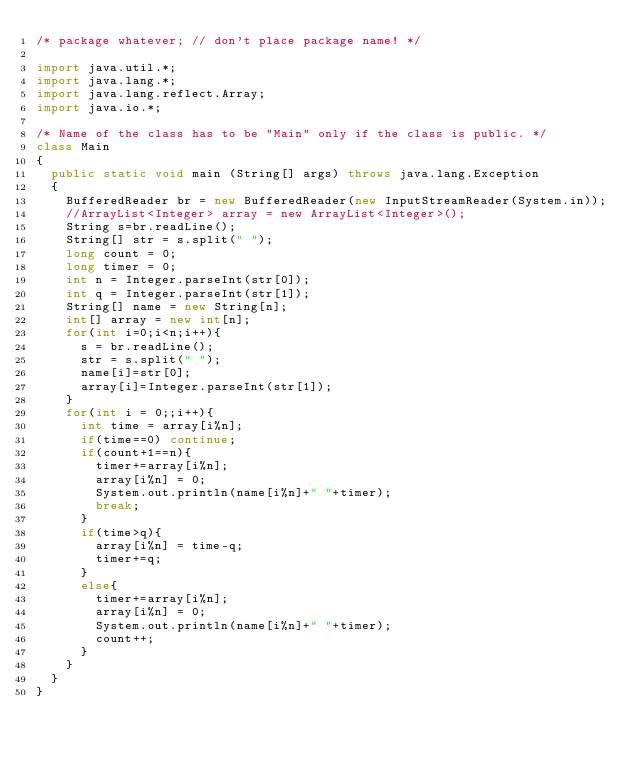Convert code to text. <code><loc_0><loc_0><loc_500><loc_500><_Java_>/* package whatever; // don't place package name! */

import java.util.*;
import java.lang.*;
import java.lang.reflect.Array;
import java.io.*;

/* Name of the class has to be "Main" only if the class is public. */
class Main
{
	public static void main (String[] args) throws java.lang.Exception
	{
		BufferedReader br = new BufferedReader(new InputStreamReader(System.in));
		//ArrayList<Integer> array = new ArrayList<Integer>();
		String s=br.readLine();
		String[] str = s.split(" ");
		long count = 0;
		long timer = 0;
		int n = Integer.parseInt(str[0]);
		int q = Integer.parseInt(str[1]);
		String[] name = new String[n];
		int[] array = new int[n];
		for(int i=0;i<n;i++){
			s = br.readLine();
			str = s.split(" ");
			name[i]=str[0];
			array[i]=Integer.parseInt(str[1]);
		}
		for(int i = 0;;i++){
			int time = array[i%n];
			if(time==0) continue;
			if(count+1==n){
				timer+=array[i%n];
				array[i%n] = 0;
				System.out.println(name[i%n]+" "+timer);
				break;
			}
			if(time>q){
				array[i%n] = time-q;
				timer+=q;
			}
			else{
				timer+=array[i%n];
				array[i%n] = 0;
				System.out.println(name[i%n]+" "+timer);
				count++;
			}	
		}
	}
}</code> 